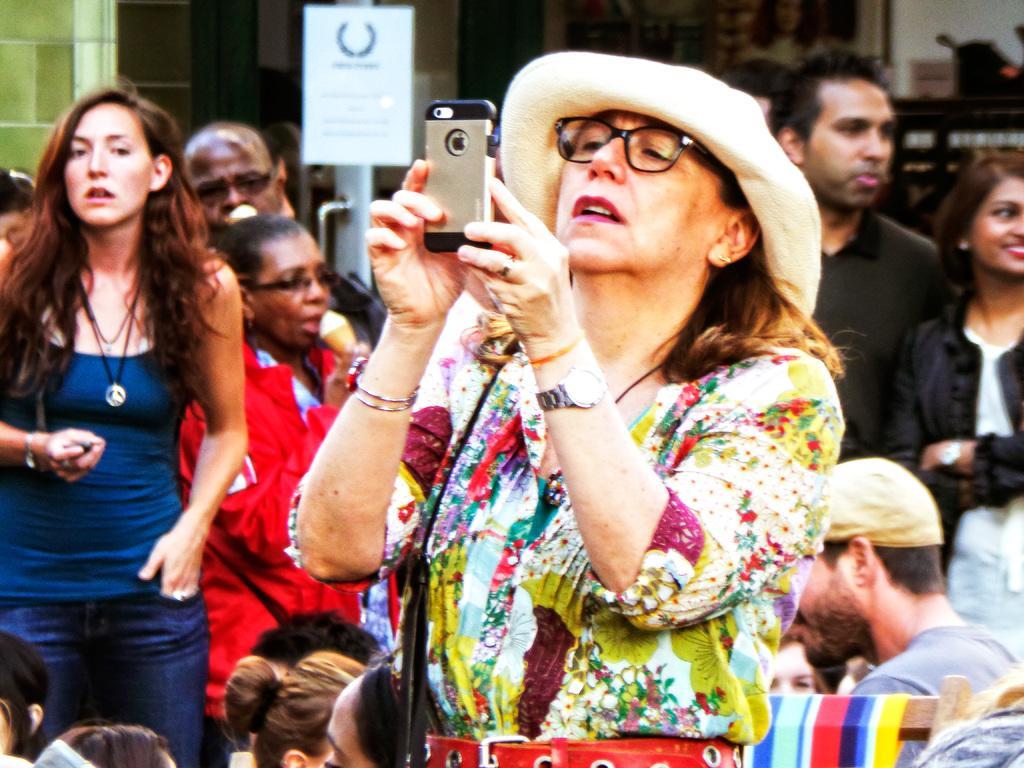Can you describe this image briefly? In the image there is a woman in floral dress and hat holding a cellphone and behind her there are many people standing. 